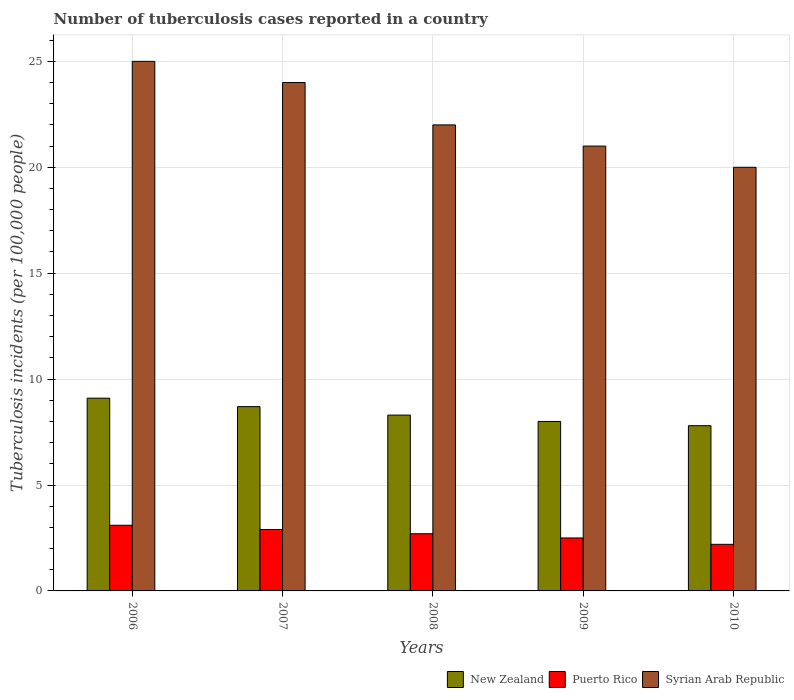How many different coloured bars are there?
Keep it short and to the point. 3. How many groups of bars are there?
Your response must be concise. 5. Are the number of bars per tick equal to the number of legend labels?
Give a very brief answer. Yes. Are the number of bars on each tick of the X-axis equal?
Make the answer very short. Yes. How many bars are there on the 1st tick from the left?
Offer a very short reply. 3. What is the label of the 1st group of bars from the left?
Your response must be concise. 2006. In how many cases, is the number of bars for a given year not equal to the number of legend labels?
Keep it short and to the point. 0. What is the number of tuberculosis cases reported in in Syrian Arab Republic in 2009?
Offer a very short reply. 21. Across all years, what is the minimum number of tuberculosis cases reported in in Puerto Rico?
Your response must be concise. 2.2. In which year was the number of tuberculosis cases reported in in Syrian Arab Republic minimum?
Your answer should be very brief. 2010. What is the total number of tuberculosis cases reported in in New Zealand in the graph?
Provide a succinct answer. 41.9. What is the difference between the number of tuberculosis cases reported in in Syrian Arab Republic in 2006 and that in 2008?
Your answer should be very brief. 3. What is the average number of tuberculosis cases reported in in Syrian Arab Republic per year?
Keep it short and to the point. 22.4. In the year 2008, what is the difference between the number of tuberculosis cases reported in in New Zealand and number of tuberculosis cases reported in in Puerto Rico?
Your answer should be very brief. 5.6. In how many years, is the number of tuberculosis cases reported in in Syrian Arab Republic greater than 5?
Make the answer very short. 5. What is the ratio of the number of tuberculosis cases reported in in Puerto Rico in 2006 to that in 2009?
Ensure brevity in your answer.  1.24. What is the difference between the highest and the second highest number of tuberculosis cases reported in in Syrian Arab Republic?
Offer a very short reply. 1. What is the difference between the highest and the lowest number of tuberculosis cases reported in in Syrian Arab Republic?
Make the answer very short. 5. What does the 3rd bar from the left in 2009 represents?
Provide a succinct answer. Syrian Arab Republic. What does the 3rd bar from the right in 2007 represents?
Provide a short and direct response. New Zealand. Is it the case that in every year, the sum of the number of tuberculosis cases reported in in Puerto Rico and number of tuberculosis cases reported in in New Zealand is greater than the number of tuberculosis cases reported in in Syrian Arab Republic?
Make the answer very short. No. What is the difference between two consecutive major ticks on the Y-axis?
Your response must be concise. 5. Does the graph contain any zero values?
Offer a terse response. No. How many legend labels are there?
Make the answer very short. 3. How are the legend labels stacked?
Give a very brief answer. Horizontal. What is the title of the graph?
Ensure brevity in your answer.  Number of tuberculosis cases reported in a country. What is the label or title of the Y-axis?
Your response must be concise. Tuberculosis incidents (per 100,0 people). What is the Tuberculosis incidents (per 100,000 people) of New Zealand in 2006?
Offer a very short reply. 9.1. What is the Tuberculosis incidents (per 100,000 people) in Puerto Rico in 2006?
Your answer should be very brief. 3.1. What is the Tuberculosis incidents (per 100,000 people) in Syrian Arab Republic in 2006?
Your response must be concise. 25. What is the Tuberculosis incidents (per 100,000 people) in New Zealand in 2007?
Provide a succinct answer. 8.7. What is the Tuberculosis incidents (per 100,000 people) of Puerto Rico in 2007?
Make the answer very short. 2.9. What is the Tuberculosis incidents (per 100,000 people) in New Zealand in 2008?
Offer a very short reply. 8.3. What is the Tuberculosis incidents (per 100,000 people) in Puerto Rico in 2008?
Offer a terse response. 2.7. What is the Tuberculosis incidents (per 100,000 people) in New Zealand in 2009?
Your answer should be compact. 8. What is the Tuberculosis incidents (per 100,000 people) of Puerto Rico in 2009?
Your answer should be compact. 2.5. What is the Tuberculosis incidents (per 100,000 people) in Syrian Arab Republic in 2010?
Keep it short and to the point. 20. Across all years, what is the maximum Tuberculosis incidents (per 100,000 people) of Syrian Arab Republic?
Give a very brief answer. 25. Across all years, what is the minimum Tuberculosis incidents (per 100,000 people) of Puerto Rico?
Your answer should be compact. 2.2. Across all years, what is the minimum Tuberculosis incidents (per 100,000 people) of Syrian Arab Republic?
Keep it short and to the point. 20. What is the total Tuberculosis incidents (per 100,000 people) in New Zealand in the graph?
Ensure brevity in your answer.  41.9. What is the total Tuberculosis incidents (per 100,000 people) in Puerto Rico in the graph?
Your response must be concise. 13.4. What is the total Tuberculosis incidents (per 100,000 people) in Syrian Arab Republic in the graph?
Your answer should be very brief. 112. What is the difference between the Tuberculosis incidents (per 100,000 people) of New Zealand in 2006 and that in 2007?
Give a very brief answer. 0.4. What is the difference between the Tuberculosis incidents (per 100,000 people) of Syrian Arab Republic in 2006 and that in 2007?
Provide a succinct answer. 1. What is the difference between the Tuberculosis incidents (per 100,000 people) in New Zealand in 2006 and that in 2008?
Give a very brief answer. 0.8. What is the difference between the Tuberculosis incidents (per 100,000 people) of Syrian Arab Republic in 2006 and that in 2008?
Offer a terse response. 3. What is the difference between the Tuberculosis incidents (per 100,000 people) in Puerto Rico in 2006 and that in 2009?
Make the answer very short. 0.6. What is the difference between the Tuberculosis incidents (per 100,000 people) in Syrian Arab Republic in 2006 and that in 2010?
Ensure brevity in your answer.  5. What is the difference between the Tuberculosis incidents (per 100,000 people) in Puerto Rico in 2007 and that in 2008?
Ensure brevity in your answer.  0.2. What is the difference between the Tuberculosis incidents (per 100,000 people) of Syrian Arab Republic in 2007 and that in 2008?
Keep it short and to the point. 2. What is the difference between the Tuberculosis incidents (per 100,000 people) in New Zealand in 2007 and that in 2009?
Offer a terse response. 0.7. What is the difference between the Tuberculosis incidents (per 100,000 people) of Puerto Rico in 2007 and that in 2009?
Provide a short and direct response. 0.4. What is the difference between the Tuberculosis incidents (per 100,000 people) of Syrian Arab Republic in 2008 and that in 2010?
Offer a very short reply. 2. What is the difference between the Tuberculosis incidents (per 100,000 people) of Puerto Rico in 2009 and that in 2010?
Your answer should be compact. 0.3. What is the difference between the Tuberculosis incidents (per 100,000 people) in New Zealand in 2006 and the Tuberculosis incidents (per 100,000 people) in Syrian Arab Republic in 2007?
Keep it short and to the point. -14.9. What is the difference between the Tuberculosis incidents (per 100,000 people) in Puerto Rico in 2006 and the Tuberculosis incidents (per 100,000 people) in Syrian Arab Republic in 2007?
Your answer should be compact. -20.9. What is the difference between the Tuberculosis incidents (per 100,000 people) of New Zealand in 2006 and the Tuberculosis incidents (per 100,000 people) of Puerto Rico in 2008?
Ensure brevity in your answer.  6.4. What is the difference between the Tuberculosis incidents (per 100,000 people) in Puerto Rico in 2006 and the Tuberculosis incidents (per 100,000 people) in Syrian Arab Republic in 2008?
Keep it short and to the point. -18.9. What is the difference between the Tuberculosis incidents (per 100,000 people) of Puerto Rico in 2006 and the Tuberculosis incidents (per 100,000 people) of Syrian Arab Republic in 2009?
Keep it short and to the point. -17.9. What is the difference between the Tuberculosis incidents (per 100,000 people) of New Zealand in 2006 and the Tuberculosis incidents (per 100,000 people) of Puerto Rico in 2010?
Ensure brevity in your answer.  6.9. What is the difference between the Tuberculosis incidents (per 100,000 people) of Puerto Rico in 2006 and the Tuberculosis incidents (per 100,000 people) of Syrian Arab Republic in 2010?
Provide a short and direct response. -16.9. What is the difference between the Tuberculosis incidents (per 100,000 people) in New Zealand in 2007 and the Tuberculosis incidents (per 100,000 people) in Puerto Rico in 2008?
Make the answer very short. 6. What is the difference between the Tuberculosis incidents (per 100,000 people) of Puerto Rico in 2007 and the Tuberculosis incidents (per 100,000 people) of Syrian Arab Republic in 2008?
Make the answer very short. -19.1. What is the difference between the Tuberculosis incidents (per 100,000 people) of New Zealand in 2007 and the Tuberculosis incidents (per 100,000 people) of Puerto Rico in 2009?
Give a very brief answer. 6.2. What is the difference between the Tuberculosis incidents (per 100,000 people) in New Zealand in 2007 and the Tuberculosis incidents (per 100,000 people) in Syrian Arab Republic in 2009?
Provide a short and direct response. -12.3. What is the difference between the Tuberculosis incidents (per 100,000 people) of Puerto Rico in 2007 and the Tuberculosis incidents (per 100,000 people) of Syrian Arab Republic in 2009?
Offer a terse response. -18.1. What is the difference between the Tuberculosis incidents (per 100,000 people) of New Zealand in 2007 and the Tuberculosis incidents (per 100,000 people) of Puerto Rico in 2010?
Make the answer very short. 6.5. What is the difference between the Tuberculosis incidents (per 100,000 people) in Puerto Rico in 2007 and the Tuberculosis incidents (per 100,000 people) in Syrian Arab Republic in 2010?
Provide a succinct answer. -17.1. What is the difference between the Tuberculosis incidents (per 100,000 people) in New Zealand in 2008 and the Tuberculosis incidents (per 100,000 people) in Puerto Rico in 2009?
Your answer should be very brief. 5.8. What is the difference between the Tuberculosis incidents (per 100,000 people) in Puerto Rico in 2008 and the Tuberculosis incidents (per 100,000 people) in Syrian Arab Republic in 2009?
Make the answer very short. -18.3. What is the difference between the Tuberculosis incidents (per 100,000 people) of New Zealand in 2008 and the Tuberculosis incidents (per 100,000 people) of Puerto Rico in 2010?
Keep it short and to the point. 6.1. What is the difference between the Tuberculosis incidents (per 100,000 people) of Puerto Rico in 2008 and the Tuberculosis incidents (per 100,000 people) of Syrian Arab Republic in 2010?
Your response must be concise. -17.3. What is the difference between the Tuberculosis incidents (per 100,000 people) in New Zealand in 2009 and the Tuberculosis incidents (per 100,000 people) in Syrian Arab Republic in 2010?
Make the answer very short. -12. What is the difference between the Tuberculosis incidents (per 100,000 people) in Puerto Rico in 2009 and the Tuberculosis incidents (per 100,000 people) in Syrian Arab Republic in 2010?
Your answer should be very brief. -17.5. What is the average Tuberculosis incidents (per 100,000 people) in New Zealand per year?
Make the answer very short. 8.38. What is the average Tuberculosis incidents (per 100,000 people) in Puerto Rico per year?
Make the answer very short. 2.68. What is the average Tuberculosis incidents (per 100,000 people) of Syrian Arab Republic per year?
Offer a terse response. 22.4. In the year 2006, what is the difference between the Tuberculosis incidents (per 100,000 people) of New Zealand and Tuberculosis incidents (per 100,000 people) of Syrian Arab Republic?
Provide a short and direct response. -15.9. In the year 2006, what is the difference between the Tuberculosis incidents (per 100,000 people) of Puerto Rico and Tuberculosis incidents (per 100,000 people) of Syrian Arab Republic?
Offer a very short reply. -21.9. In the year 2007, what is the difference between the Tuberculosis incidents (per 100,000 people) of New Zealand and Tuberculosis incidents (per 100,000 people) of Syrian Arab Republic?
Provide a succinct answer. -15.3. In the year 2007, what is the difference between the Tuberculosis incidents (per 100,000 people) of Puerto Rico and Tuberculosis incidents (per 100,000 people) of Syrian Arab Republic?
Offer a terse response. -21.1. In the year 2008, what is the difference between the Tuberculosis incidents (per 100,000 people) in New Zealand and Tuberculosis incidents (per 100,000 people) in Syrian Arab Republic?
Your answer should be compact. -13.7. In the year 2008, what is the difference between the Tuberculosis incidents (per 100,000 people) of Puerto Rico and Tuberculosis incidents (per 100,000 people) of Syrian Arab Republic?
Give a very brief answer. -19.3. In the year 2009, what is the difference between the Tuberculosis incidents (per 100,000 people) in New Zealand and Tuberculosis incidents (per 100,000 people) in Syrian Arab Republic?
Make the answer very short. -13. In the year 2009, what is the difference between the Tuberculosis incidents (per 100,000 people) of Puerto Rico and Tuberculosis incidents (per 100,000 people) of Syrian Arab Republic?
Provide a succinct answer. -18.5. In the year 2010, what is the difference between the Tuberculosis incidents (per 100,000 people) in Puerto Rico and Tuberculosis incidents (per 100,000 people) in Syrian Arab Republic?
Ensure brevity in your answer.  -17.8. What is the ratio of the Tuberculosis incidents (per 100,000 people) of New Zealand in 2006 to that in 2007?
Your response must be concise. 1.05. What is the ratio of the Tuberculosis incidents (per 100,000 people) in Puerto Rico in 2006 to that in 2007?
Provide a short and direct response. 1.07. What is the ratio of the Tuberculosis incidents (per 100,000 people) in Syrian Arab Republic in 2006 to that in 2007?
Provide a short and direct response. 1.04. What is the ratio of the Tuberculosis incidents (per 100,000 people) of New Zealand in 2006 to that in 2008?
Provide a succinct answer. 1.1. What is the ratio of the Tuberculosis incidents (per 100,000 people) of Puerto Rico in 2006 to that in 2008?
Provide a short and direct response. 1.15. What is the ratio of the Tuberculosis incidents (per 100,000 people) in Syrian Arab Republic in 2006 to that in 2008?
Provide a short and direct response. 1.14. What is the ratio of the Tuberculosis incidents (per 100,000 people) of New Zealand in 2006 to that in 2009?
Provide a succinct answer. 1.14. What is the ratio of the Tuberculosis incidents (per 100,000 people) in Puerto Rico in 2006 to that in 2009?
Your answer should be compact. 1.24. What is the ratio of the Tuberculosis incidents (per 100,000 people) of Syrian Arab Republic in 2006 to that in 2009?
Give a very brief answer. 1.19. What is the ratio of the Tuberculosis incidents (per 100,000 people) of New Zealand in 2006 to that in 2010?
Your answer should be compact. 1.17. What is the ratio of the Tuberculosis incidents (per 100,000 people) in Puerto Rico in 2006 to that in 2010?
Keep it short and to the point. 1.41. What is the ratio of the Tuberculosis incidents (per 100,000 people) of New Zealand in 2007 to that in 2008?
Offer a very short reply. 1.05. What is the ratio of the Tuberculosis incidents (per 100,000 people) in Puerto Rico in 2007 to that in 2008?
Your response must be concise. 1.07. What is the ratio of the Tuberculosis incidents (per 100,000 people) in Syrian Arab Republic in 2007 to that in 2008?
Ensure brevity in your answer.  1.09. What is the ratio of the Tuberculosis incidents (per 100,000 people) of New Zealand in 2007 to that in 2009?
Your answer should be very brief. 1.09. What is the ratio of the Tuberculosis incidents (per 100,000 people) of Puerto Rico in 2007 to that in 2009?
Provide a short and direct response. 1.16. What is the ratio of the Tuberculosis incidents (per 100,000 people) in Syrian Arab Republic in 2007 to that in 2009?
Offer a terse response. 1.14. What is the ratio of the Tuberculosis incidents (per 100,000 people) in New Zealand in 2007 to that in 2010?
Keep it short and to the point. 1.12. What is the ratio of the Tuberculosis incidents (per 100,000 people) in Puerto Rico in 2007 to that in 2010?
Your answer should be compact. 1.32. What is the ratio of the Tuberculosis incidents (per 100,000 people) in New Zealand in 2008 to that in 2009?
Your response must be concise. 1.04. What is the ratio of the Tuberculosis incidents (per 100,000 people) of Puerto Rico in 2008 to that in 2009?
Provide a succinct answer. 1.08. What is the ratio of the Tuberculosis incidents (per 100,000 people) in Syrian Arab Republic in 2008 to that in 2009?
Provide a short and direct response. 1.05. What is the ratio of the Tuberculosis incidents (per 100,000 people) of New Zealand in 2008 to that in 2010?
Your answer should be compact. 1.06. What is the ratio of the Tuberculosis incidents (per 100,000 people) of Puerto Rico in 2008 to that in 2010?
Ensure brevity in your answer.  1.23. What is the ratio of the Tuberculosis incidents (per 100,000 people) of Syrian Arab Republic in 2008 to that in 2010?
Provide a short and direct response. 1.1. What is the ratio of the Tuberculosis incidents (per 100,000 people) of New Zealand in 2009 to that in 2010?
Provide a short and direct response. 1.03. What is the ratio of the Tuberculosis incidents (per 100,000 people) of Puerto Rico in 2009 to that in 2010?
Your answer should be compact. 1.14. What is the difference between the highest and the second highest Tuberculosis incidents (per 100,000 people) in New Zealand?
Your answer should be very brief. 0.4. What is the difference between the highest and the lowest Tuberculosis incidents (per 100,000 people) in Puerto Rico?
Ensure brevity in your answer.  0.9. What is the difference between the highest and the lowest Tuberculosis incidents (per 100,000 people) in Syrian Arab Republic?
Offer a terse response. 5. 